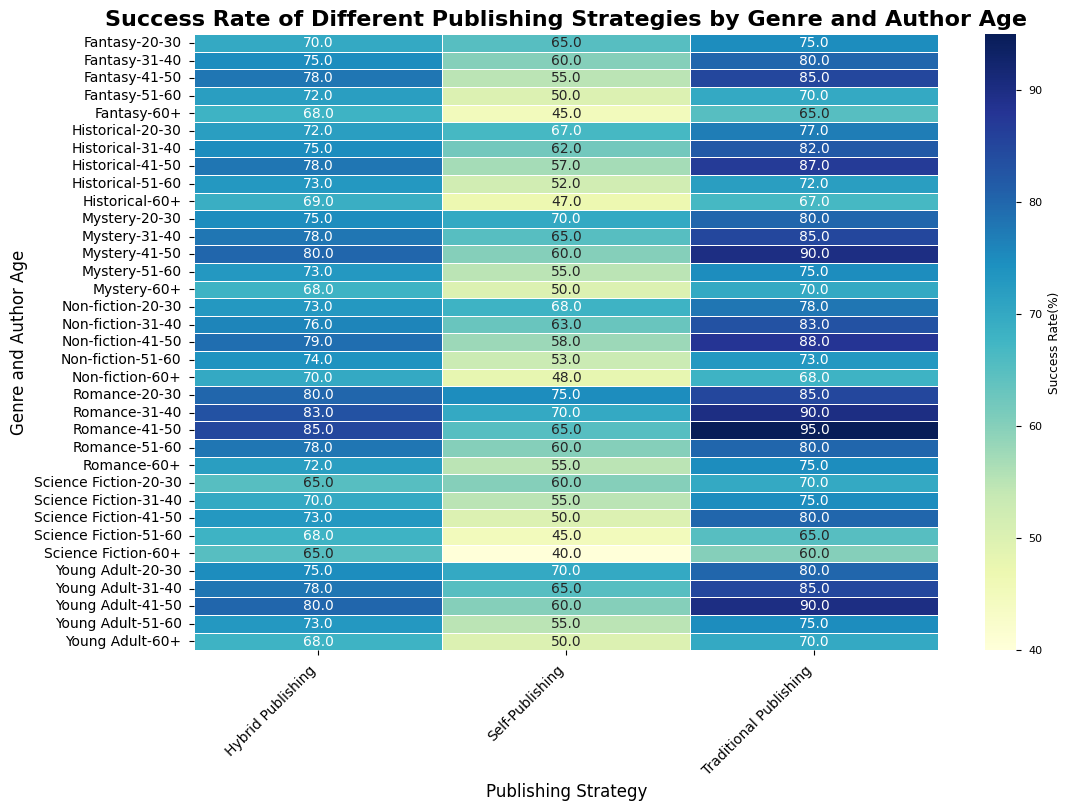Which genre and age group has the highest success rate for Traditional Publishing? Look at the highest value in the Traditional Publishing column and find the corresponding Genre and Author Age row.
Answer: Romance, 41-50 Which genre has the lowest success rate across all publishing strategies for authors aged 20-30? Compare the success rates for Traditional Publishing, Self-Publishing, and Hybrid Publishing in the 20-30 age group for all genres. Find the genre with the lowest value of these.
Answer: Science Fiction Which publishing strategy has the highest average success rate in the Mystery genre? Calculate the average success rate for Traditional Publishing, Self-Publishing, and Hybrid Publishing in the Mystery genre by summing up the success rates for each strategy and dividing by the number of age groups, then compare the averages.
Answer: Traditional Publishing Which author age group generally shows the weakest success rates across all genres and publishing strategies? Look at each genre’s success rates in all publishing strategies and find the age group with the most consistently low values.
Answer: 60+ How much higher is the success rate for Hybrid Publishing versus Self-Publishing in the Fantasy genre for authors aged 31-40? Subtract the Self-Publishing success rate from the Hybrid Publishing success rate for the Fantasy genre in the 31-40 age group.
Answer: 15% For the Non-fiction genre, compare the success rates of Traditional Publishing and Hybrid Publishing across all age groups and determine which has the higher average. Calculate the average success rate for both Traditional Publishing and Hybrid Publishing across all age groups in Non-fiction by summing the values and dividing by the number of age groups. Compare the two averages.
Answer: Traditional Publishing Which genre shows the most consistent success rate for Self-Publishing across different age groups? Look at the Self-Publishing success rates for each genre and determine which genre has the smallest variation or consistent values across all age groups.
Answer: Historical Identify the genre-age group combination that has the closest success rates among all three publishing strategies. Analyze the differences in success rates for each genre and age group and find the row where the values are the closest to each other.
Answer: Historical, 60+ 